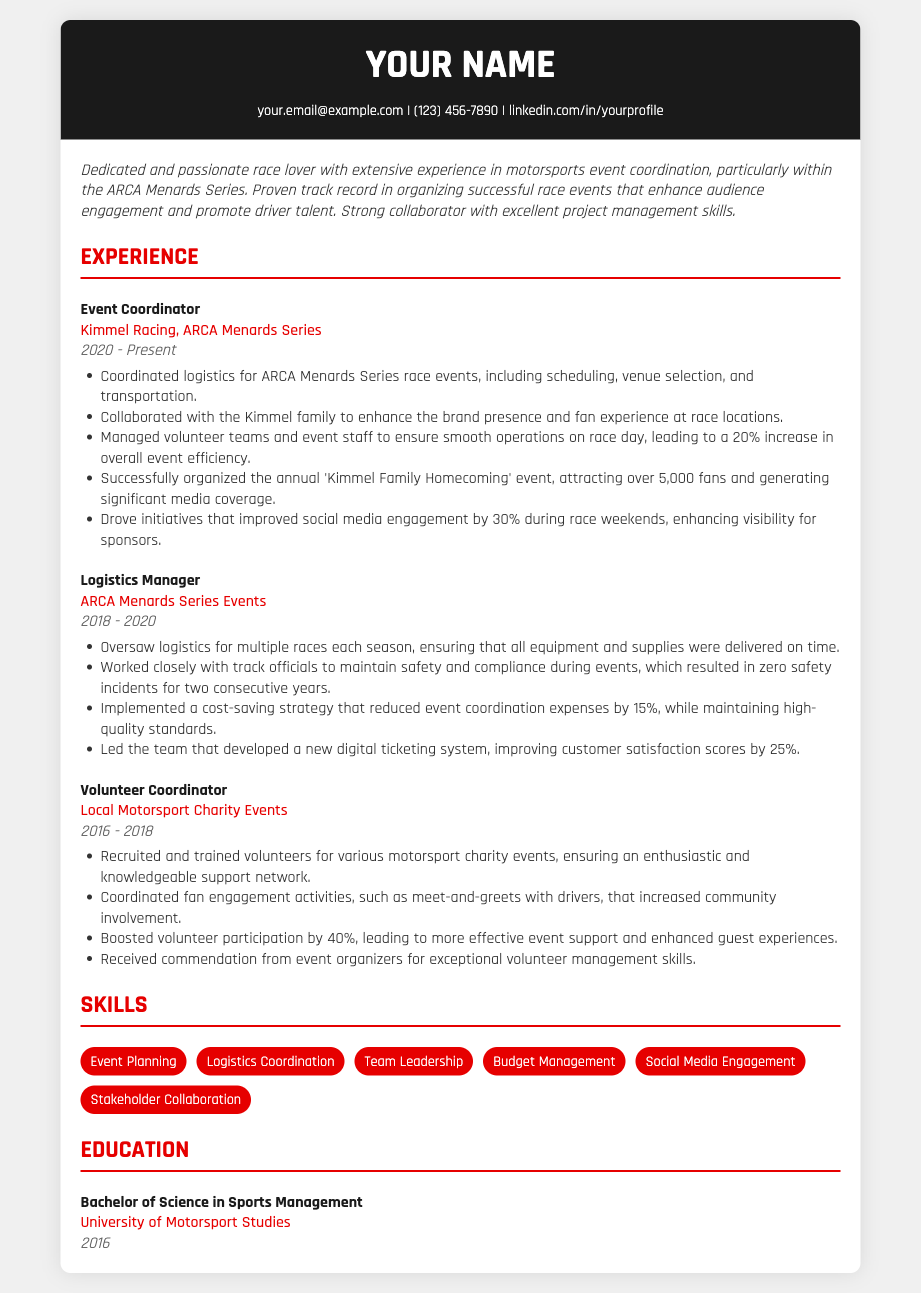what is the current position held? The current position held is listed under experience in the resume.
Answer: Event Coordinator which series is primarily focused on in this resume? The resume highlights the series where the majority of experience is gained.
Answer: ARCA Menards Series what was the efficiency increase achieved on race day? The document states a specific percentage increase in overall event efficiency attributed to efforts on race day.
Answer: 20% how many years did the candidate work as a Logistics Manager? This refers to the time span listed under the experience section for the Logistics Manager position.
Answer: 2 years what educational qualification does the candidate have? The section on education provides the degree obtained by the candidate.
Answer: Bachelor of Science in Sports Management which family is mentioned in connection with the candidate's work? The resume mentions a specific family that the candidate collaborated with for enhancing brand presence.
Answer: Kimmel family what was the percentage of improved social media engagement during race weekends? The resume specifies a certain percentage increase in social media engagement related to race weekends.
Answer: 30% how many fans attended the 'Kimmel Family Homecoming' event? This information is available in the experience section stating the outcome of a particular event.
Answer: over 5,000 fans 